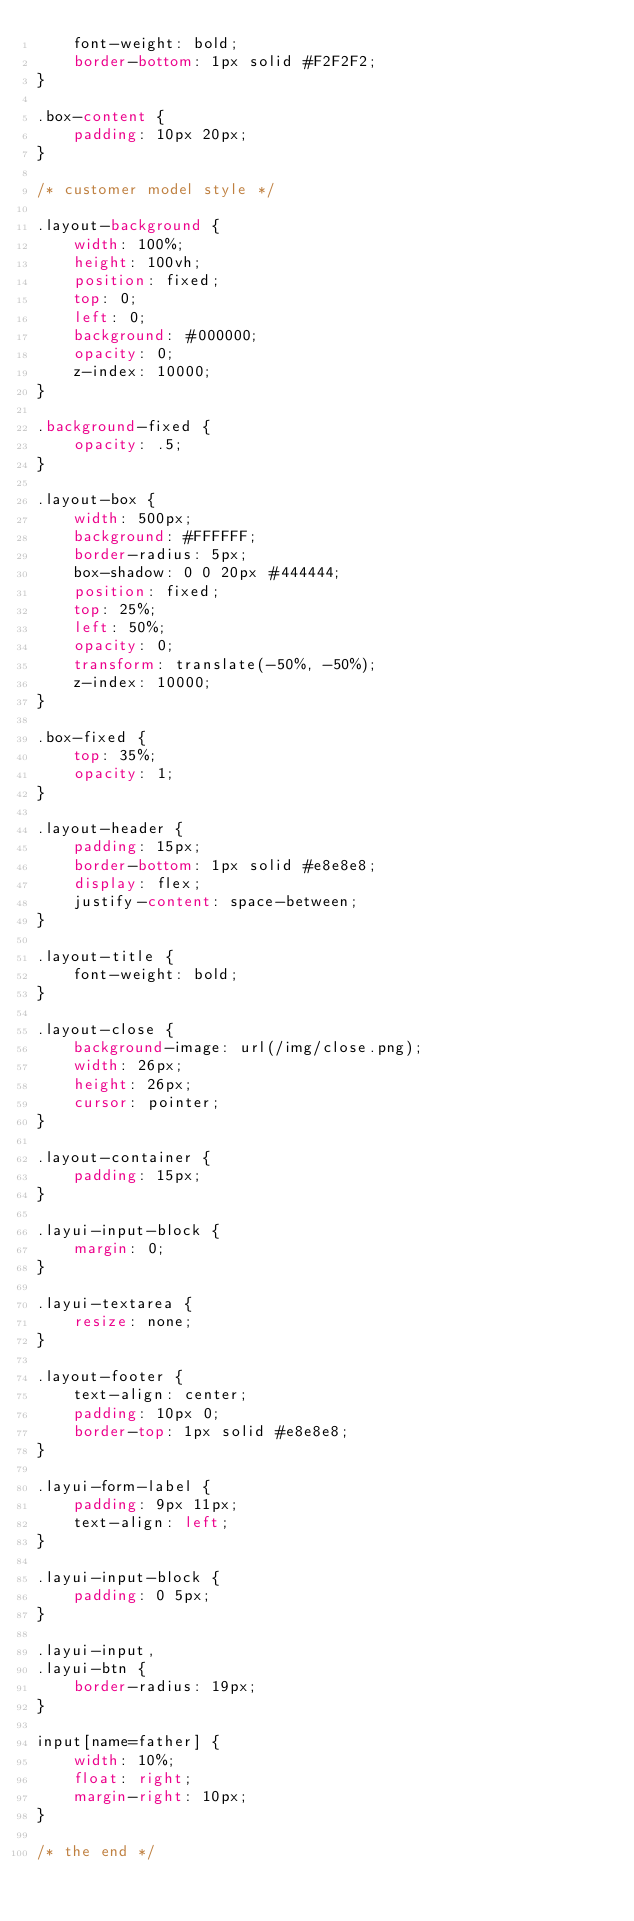<code> <loc_0><loc_0><loc_500><loc_500><_CSS_>    font-weight: bold;
    border-bottom: 1px solid #F2F2F2;
}

.box-content {
    padding: 10px 20px;
}

/* customer model style */

.layout-background {
    width: 100%;
    height: 100vh;
    position: fixed;
    top: 0;
    left: 0;
    background: #000000;
    opacity: 0;
    z-index: 10000;
}

.background-fixed {
    opacity: .5;
}

.layout-box {
    width: 500px;
    background: #FFFFFF;
    border-radius: 5px;
    box-shadow: 0 0 20px #444444;
    position: fixed;
    top: 25%;
    left: 50%;
    opacity: 0;
    transform: translate(-50%, -50%);
    z-index: 10000;
}

.box-fixed {
    top: 35%;
    opacity: 1;
}

.layout-header {
    padding: 15px;
    border-bottom: 1px solid #e8e8e8;
    display: flex;
    justify-content: space-between;
}

.layout-title {
    font-weight: bold;
}

.layout-close {
    background-image: url(/img/close.png);
    width: 26px;
    height: 26px;
    cursor: pointer;
}

.layout-container {
    padding: 15px;
}

.layui-input-block {
    margin: 0;
}

.layui-textarea {
    resize: none;
}

.layout-footer {
    text-align: center;
    padding: 10px 0;
    border-top: 1px solid #e8e8e8;
}

.layui-form-label {
    padding: 9px 11px;
    text-align: left;
}

.layui-input-block {
    padding: 0 5px;
}

.layui-input,
.layui-btn {
    border-radius: 19px;
}

input[name=father] {
    width: 10%;
    float: right;
    margin-right: 10px;
}

/* the end */</code> 